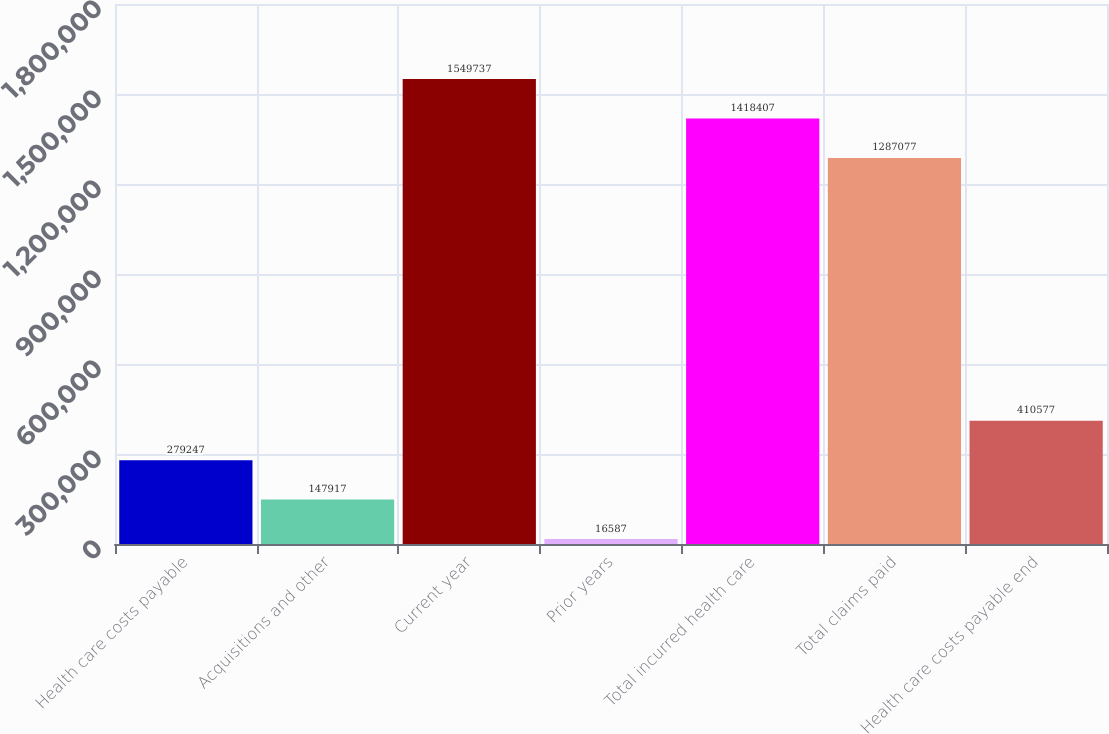Convert chart to OTSL. <chart><loc_0><loc_0><loc_500><loc_500><bar_chart><fcel>Health care costs payable<fcel>Acquisitions and other<fcel>Current year<fcel>Prior years<fcel>Total incurred health care<fcel>Total claims paid<fcel>Health care costs payable end<nl><fcel>279247<fcel>147917<fcel>1.54974e+06<fcel>16587<fcel>1.41841e+06<fcel>1.28708e+06<fcel>410577<nl></chart> 